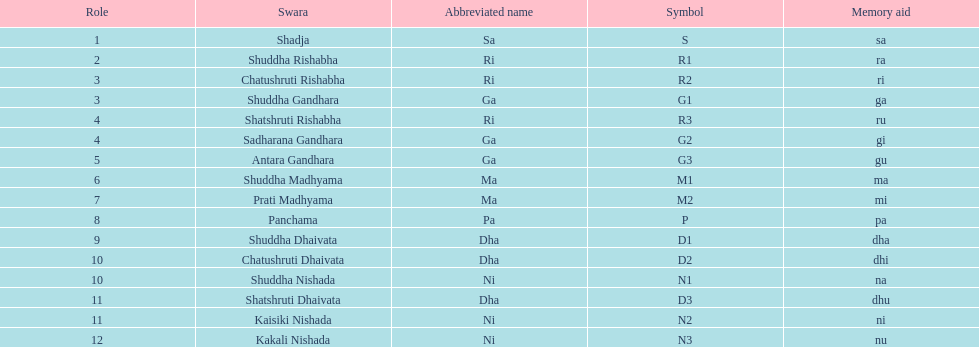What swara is above shatshruti dhaivata? Shuddha Nishada. 